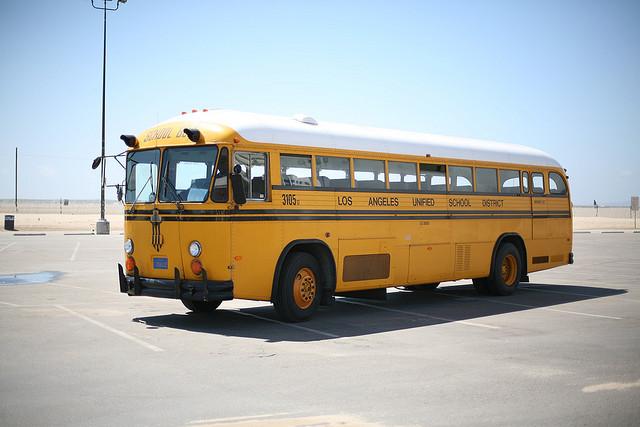How many tires on the bus?
Concise answer only. 4. What is directly behind the back of the bus?
Keep it brief. Parking lot. What is the number on the bus?
Keep it brief. 3105. What school district?
Concise answer only. Los angeles. How many lights are at the top front of the bus?
Write a very short answer. 2. How many busses do you see?
Write a very short answer. 1. How many buses are shown?
Answer briefly. 1. What is the color of the bus?
Write a very short answer. Yellow. 